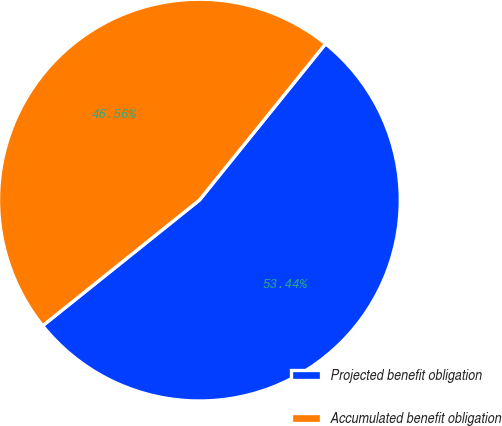<chart> <loc_0><loc_0><loc_500><loc_500><pie_chart><fcel>Projected benefit obligation<fcel>Accumulated benefit obligation<nl><fcel>53.44%<fcel>46.56%<nl></chart> 